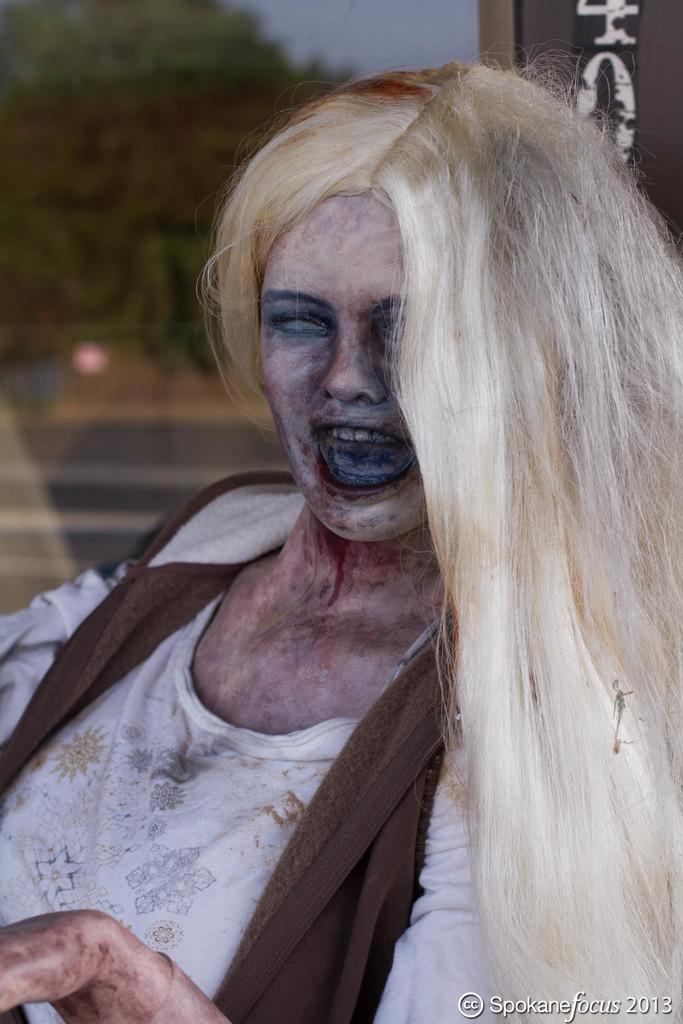Who is the main subject in the image? There is a woman in the center of the image. What can be seen in the background of the image? There is a tree in the background of the image. What force is acting upon the woman in the image? There is no indication of any force acting upon the woman in the image. What type of soil can be seen around the tree in the image? The image does not provide enough detail to determine the type of soil around the tree. 